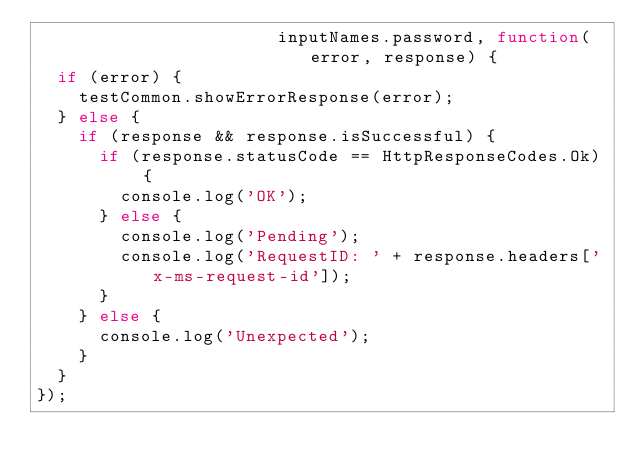<code> <loc_0><loc_0><loc_500><loc_500><_JavaScript_>                       inputNames.password, function(error, response) {
  if (error) {
    testCommon.showErrorResponse(error);
  } else {
    if (response && response.isSuccessful) {
      if (response.statusCode == HttpResponseCodes.Ok) {
        console.log('OK');
      } else {
        console.log('Pending');
        console.log('RequestID: ' + response.headers['x-ms-request-id']);
      }
    } else {
      console.log('Unexpected');
    }
  }
});

</code> 